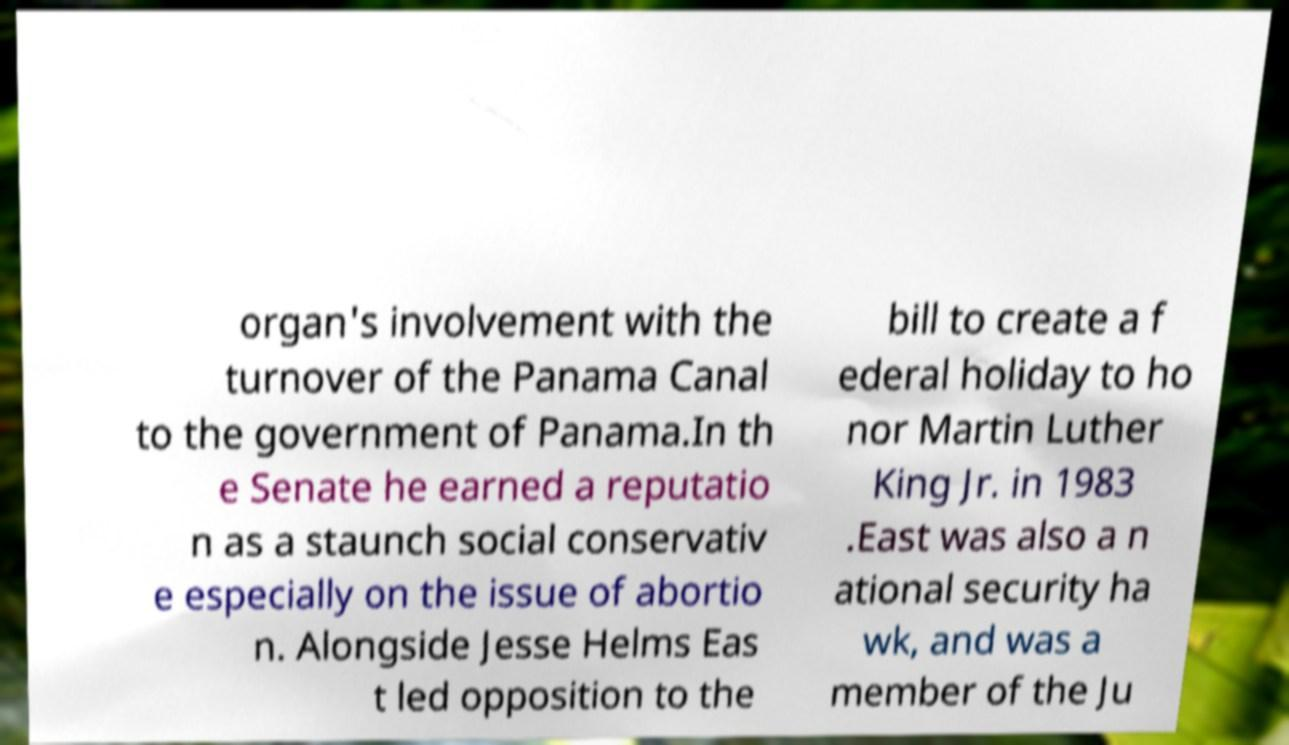Please read and relay the text visible in this image. What does it say? organ's involvement with the turnover of the Panama Canal to the government of Panama.In th e Senate he earned a reputatio n as a staunch social conservativ e especially on the issue of abortio n. Alongside Jesse Helms Eas t led opposition to the bill to create a f ederal holiday to ho nor Martin Luther King Jr. in 1983 .East was also a n ational security ha wk, and was a member of the Ju 